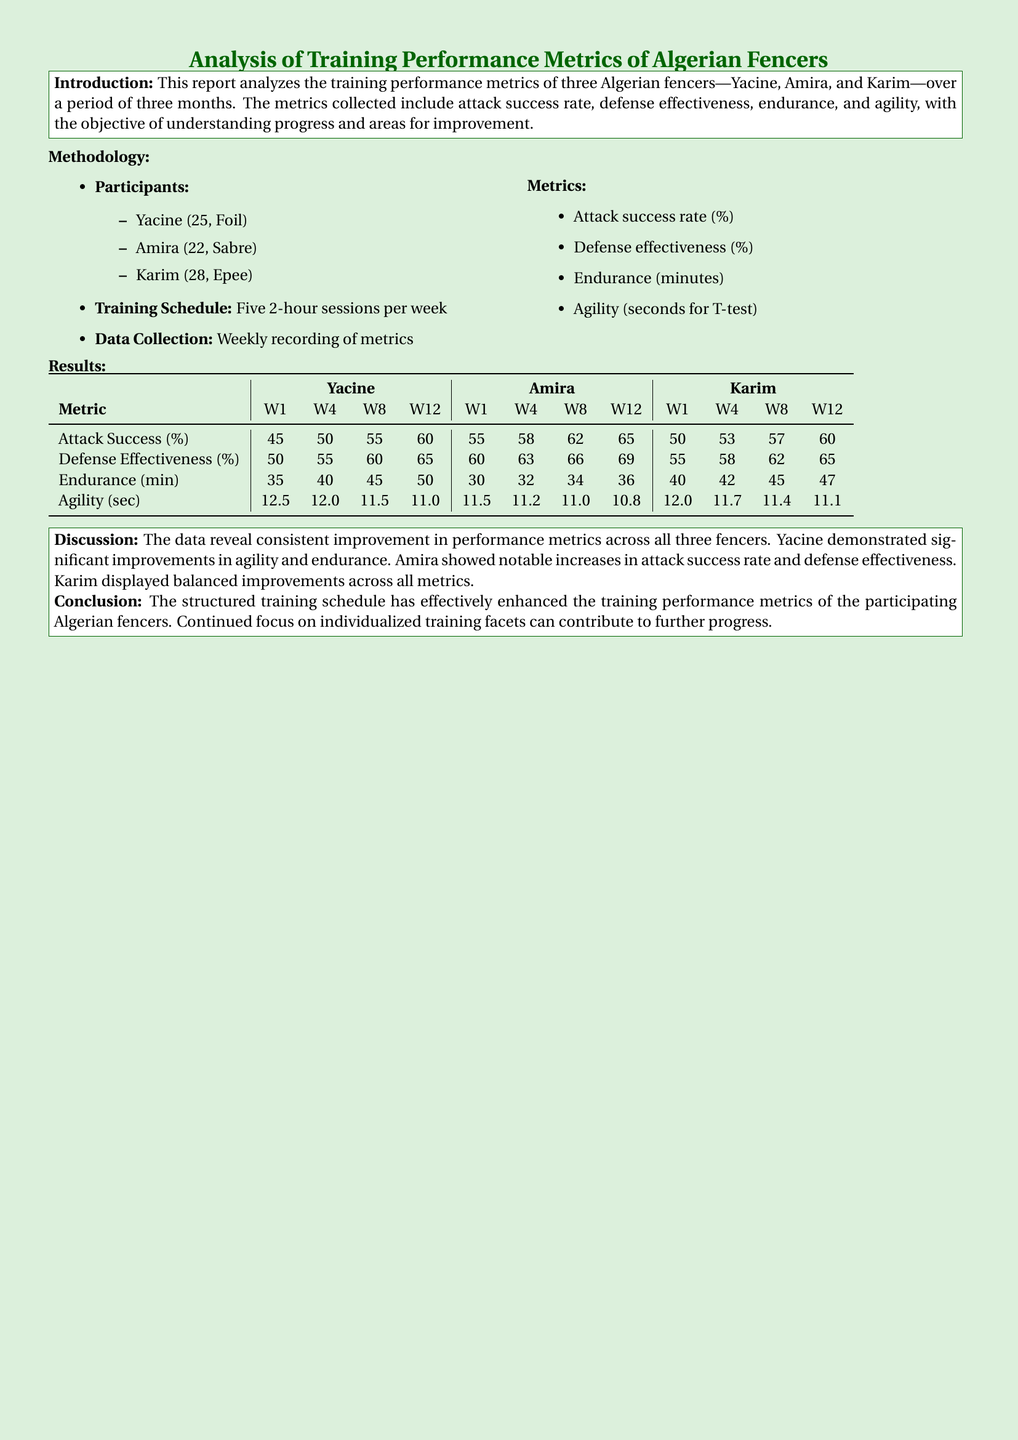What are the names of the fencers? The document lists the fencers as Yacine, Amira, and Karim.
Answer: Yacine, Amira, Karim How many training sessions per week were conducted? The training schedule in the methodology specifies five sessions per week.
Answer: Five What was Yacine's attack success rate at Week 12? The results table shows Yacine's attack success rate was 60% at Week 12.
Answer: 60 Which metric showed improvement for Amira? The discussion mentions that Amira showed notable increases in attack success rate and defense effectiveness.
Answer: Attack success rate, defense effectiveness Which fencer had the highest endurance at Week 12? The table shows that Karim had an endurance of 47 minutes at Week 12, the highest among the three fencers.
Answer: Karim What does the report conclude about the training schedule? The conclusion states that the structured training schedule has effectively enhanced the training performance metrics.
Answer: Effectively enhanced What was the agility time of Karim at Week 8? The results table indicates that Karim's agility time at Week 8 was 11.4 seconds.
Answer: 11.4 How old is Amira? The methodology section specifies that Amira is 22 years old.
Answer: 22 